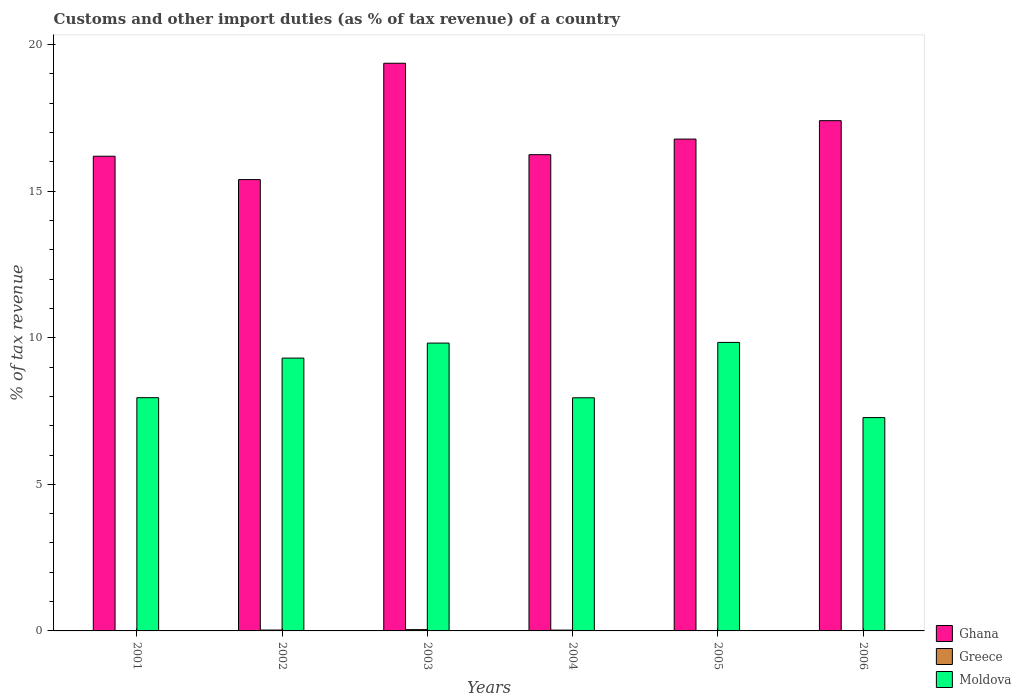How many different coloured bars are there?
Provide a short and direct response. 3. How many groups of bars are there?
Make the answer very short. 6. Are the number of bars per tick equal to the number of legend labels?
Provide a succinct answer. No. How many bars are there on the 4th tick from the right?
Your answer should be compact. 3. What is the percentage of tax revenue from customs in Moldova in 2002?
Your answer should be compact. 9.31. Across all years, what is the maximum percentage of tax revenue from customs in Moldova?
Give a very brief answer. 9.84. Across all years, what is the minimum percentage of tax revenue from customs in Ghana?
Your answer should be very brief. 15.4. What is the total percentage of tax revenue from customs in Ghana in the graph?
Offer a very short reply. 101.38. What is the difference between the percentage of tax revenue from customs in Greece in 2004 and that in 2005?
Ensure brevity in your answer.  0.02. What is the difference between the percentage of tax revenue from customs in Ghana in 2003 and the percentage of tax revenue from customs in Moldova in 2002?
Keep it short and to the point. 10.06. What is the average percentage of tax revenue from customs in Moldova per year?
Your answer should be compact. 8.69. In the year 2005, what is the difference between the percentage of tax revenue from customs in Moldova and percentage of tax revenue from customs in Ghana?
Offer a terse response. -6.94. In how many years, is the percentage of tax revenue from customs in Moldova greater than 11 %?
Offer a terse response. 0. What is the ratio of the percentage of tax revenue from customs in Ghana in 2002 to that in 2005?
Your response must be concise. 0.92. What is the difference between the highest and the second highest percentage of tax revenue from customs in Ghana?
Your answer should be compact. 1.96. What is the difference between the highest and the lowest percentage of tax revenue from customs in Ghana?
Make the answer very short. 3.97. In how many years, is the percentage of tax revenue from customs in Greece greater than the average percentage of tax revenue from customs in Greece taken over all years?
Ensure brevity in your answer.  3. Is the sum of the percentage of tax revenue from customs in Ghana in 2001 and 2003 greater than the maximum percentage of tax revenue from customs in Greece across all years?
Provide a succinct answer. Yes. Is it the case that in every year, the sum of the percentage of tax revenue from customs in Greece and percentage of tax revenue from customs in Ghana is greater than the percentage of tax revenue from customs in Moldova?
Your answer should be compact. Yes. Are all the bars in the graph horizontal?
Your answer should be very brief. No. Are the values on the major ticks of Y-axis written in scientific E-notation?
Provide a short and direct response. No. Where does the legend appear in the graph?
Provide a succinct answer. Bottom right. How many legend labels are there?
Your answer should be compact. 3. What is the title of the graph?
Ensure brevity in your answer.  Customs and other import duties (as % of tax revenue) of a country. Does "Cabo Verde" appear as one of the legend labels in the graph?
Offer a terse response. No. What is the label or title of the Y-axis?
Your response must be concise. % of tax revenue. What is the % of tax revenue of Ghana in 2001?
Offer a terse response. 16.19. What is the % of tax revenue in Greece in 2001?
Your response must be concise. 0. What is the % of tax revenue of Moldova in 2001?
Offer a very short reply. 7.96. What is the % of tax revenue in Ghana in 2002?
Provide a short and direct response. 15.4. What is the % of tax revenue of Greece in 2002?
Offer a terse response. 0.03. What is the % of tax revenue of Moldova in 2002?
Your response must be concise. 9.31. What is the % of tax revenue in Ghana in 2003?
Provide a succinct answer. 19.36. What is the % of tax revenue of Greece in 2003?
Offer a terse response. 0.04. What is the % of tax revenue in Moldova in 2003?
Keep it short and to the point. 9.82. What is the % of tax revenue of Ghana in 2004?
Your answer should be very brief. 16.25. What is the % of tax revenue in Greece in 2004?
Ensure brevity in your answer.  0.03. What is the % of tax revenue in Moldova in 2004?
Your response must be concise. 7.95. What is the % of tax revenue of Ghana in 2005?
Offer a terse response. 16.78. What is the % of tax revenue in Greece in 2005?
Offer a very short reply. 0.01. What is the % of tax revenue in Moldova in 2005?
Keep it short and to the point. 9.84. What is the % of tax revenue in Ghana in 2006?
Offer a terse response. 17.41. What is the % of tax revenue of Greece in 2006?
Provide a succinct answer. 0.01. What is the % of tax revenue of Moldova in 2006?
Ensure brevity in your answer.  7.28. Across all years, what is the maximum % of tax revenue in Ghana?
Offer a very short reply. 19.36. Across all years, what is the maximum % of tax revenue of Greece?
Provide a short and direct response. 0.04. Across all years, what is the maximum % of tax revenue in Moldova?
Your answer should be compact. 9.84. Across all years, what is the minimum % of tax revenue of Ghana?
Ensure brevity in your answer.  15.4. Across all years, what is the minimum % of tax revenue in Moldova?
Offer a very short reply. 7.28. What is the total % of tax revenue of Ghana in the graph?
Your answer should be compact. 101.38. What is the total % of tax revenue of Greece in the graph?
Your response must be concise. 0.12. What is the total % of tax revenue in Moldova in the graph?
Make the answer very short. 52.15. What is the difference between the % of tax revenue in Ghana in 2001 and that in 2002?
Your response must be concise. 0.8. What is the difference between the % of tax revenue in Moldova in 2001 and that in 2002?
Provide a short and direct response. -1.35. What is the difference between the % of tax revenue in Ghana in 2001 and that in 2003?
Ensure brevity in your answer.  -3.17. What is the difference between the % of tax revenue of Moldova in 2001 and that in 2003?
Keep it short and to the point. -1.86. What is the difference between the % of tax revenue in Ghana in 2001 and that in 2004?
Your response must be concise. -0.05. What is the difference between the % of tax revenue in Moldova in 2001 and that in 2004?
Your answer should be compact. 0. What is the difference between the % of tax revenue of Ghana in 2001 and that in 2005?
Your answer should be compact. -0.58. What is the difference between the % of tax revenue of Moldova in 2001 and that in 2005?
Ensure brevity in your answer.  -1.89. What is the difference between the % of tax revenue of Ghana in 2001 and that in 2006?
Make the answer very short. -1.21. What is the difference between the % of tax revenue of Moldova in 2001 and that in 2006?
Make the answer very short. 0.68. What is the difference between the % of tax revenue in Ghana in 2002 and that in 2003?
Provide a short and direct response. -3.97. What is the difference between the % of tax revenue in Greece in 2002 and that in 2003?
Offer a very short reply. -0.01. What is the difference between the % of tax revenue in Moldova in 2002 and that in 2003?
Your answer should be compact. -0.51. What is the difference between the % of tax revenue in Ghana in 2002 and that in 2004?
Give a very brief answer. -0.85. What is the difference between the % of tax revenue of Greece in 2002 and that in 2004?
Your answer should be very brief. 0. What is the difference between the % of tax revenue of Moldova in 2002 and that in 2004?
Offer a very short reply. 1.35. What is the difference between the % of tax revenue in Ghana in 2002 and that in 2005?
Give a very brief answer. -1.38. What is the difference between the % of tax revenue in Greece in 2002 and that in 2005?
Your answer should be compact. 0.02. What is the difference between the % of tax revenue of Moldova in 2002 and that in 2005?
Ensure brevity in your answer.  -0.54. What is the difference between the % of tax revenue in Ghana in 2002 and that in 2006?
Give a very brief answer. -2.01. What is the difference between the % of tax revenue in Greece in 2002 and that in 2006?
Make the answer very short. 0.02. What is the difference between the % of tax revenue of Moldova in 2002 and that in 2006?
Your response must be concise. 2.03. What is the difference between the % of tax revenue in Ghana in 2003 and that in 2004?
Offer a terse response. 3.12. What is the difference between the % of tax revenue in Greece in 2003 and that in 2004?
Offer a very short reply. 0.02. What is the difference between the % of tax revenue in Moldova in 2003 and that in 2004?
Give a very brief answer. 1.87. What is the difference between the % of tax revenue of Ghana in 2003 and that in 2005?
Your response must be concise. 2.59. What is the difference between the % of tax revenue in Greece in 2003 and that in 2005?
Your answer should be very brief. 0.04. What is the difference between the % of tax revenue in Moldova in 2003 and that in 2005?
Provide a succinct answer. -0.02. What is the difference between the % of tax revenue of Ghana in 2003 and that in 2006?
Keep it short and to the point. 1.96. What is the difference between the % of tax revenue of Greece in 2003 and that in 2006?
Your response must be concise. 0.03. What is the difference between the % of tax revenue of Moldova in 2003 and that in 2006?
Provide a succinct answer. 2.54. What is the difference between the % of tax revenue in Ghana in 2004 and that in 2005?
Offer a terse response. -0.53. What is the difference between the % of tax revenue of Greece in 2004 and that in 2005?
Your response must be concise. 0.02. What is the difference between the % of tax revenue in Moldova in 2004 and that in 2005?
Give a very brief answer. -1.89. What is the difference between the % of tax revenue in Ghana in 2004 and that in 2006?
Provide a short and direct response. -1.16. What is the difference between the % of tax revenue of Greece in 2004 and that in 2006?
Your answer should be very brief. 0.02. What is the difference between the % of tax revenue of Moldova in 2004 and that in 2006?
Provide a short and direct response. 0.68. What is the difference between the % of tax revenue in Ghana in 2005 and that in 2006?
Give a very brief answer. -0.63. What is the difference between the % of tax revenue in Greece in 2005 and that in 2006?
Your answer should be compact. -0. What is the difference between the % of tax revenue in Moldova in 2005 and that in 2006?
Offer a very short reply. 2.56. What is the difference between the % of tax revenue in Ghana in 2001 and the % of tax revenue in Greece in 2002?
Make the answer very short. 16.16. What is the difference between the % of tax revenue of Ghana in 2001 and the % of tax revenue of Moldova in 2002?
Keep it short and to the point. 6.89. What is the difference between the % of tax revenue of Ghana in 2001 and the % of tax revenue of Greece in 2003?
Your answer should be compact. 16.15. What is the difference between the % of tax revenue of Ghana in 2001 and the % of tax revenue of Moldova in 2003?
Provide a succinct answer. 6.37. What is the difference between the % of tax revenue in Ghana in 2001 and the % of tax revenue in Greece in 2004?
Keep it short and to the point. 16.17. What is the difference between the % of tax revenue of Ghana in 2001 and the % of tax revenue of Moldova in 2004?
Offer a terse response. 8.24. What is the difference between the % of tax revenue in Ghana in 2001 and the % of tax revenue in Greece in 2005?
Ensure brevity in your answer.  16.19. What is the difference between the % of tax revenue of Ghana in 2001 and the % of tax revenue of Moldova in 2005?
Ensure brevity in your answer.  6.35. What is the difference between the % of tax revenue of Ghana in 2001 and the % of tax revenue of Greece in 2006?
Make the answer very short. 16.18. What is the difference between the % of tax revenue in Ghana in 2001 and the % of tax revenue in Moldova in 2006?
Your answer should be compact. 8.92. What is the difference between the % of tax revenue in Ghana in 2002 and the % of tax revenue in Greece in 2003?
Your answer should be very brief. 15.35. What is the difference between the % of tax revenue in Ghana in 2002 and the % of tax revenue in Moldova in 2003?
Make the answer very short. 5.58. What is the difference between the % of tax revenue of Greece in 2002 and the % of tax revenue of Moldova in 2003?
Ensure brevity in your answer.  -9.79. What is the difference between the % of tax revenue of Ghana in 2002 and the % of tax revenue of Greece in 2004?
Offer a very short reply. 15.37. What is the difference between the % of tax revenue in Ghana in 2002 and the % of tax revenue in Moldova in 2004?
Give a very brief answer. 7.44. What is the difference between the % of tax revenue in Greece in 2002 and the % of tax revenue in Moldova in 2004?
Keep it short and to the point. -7.92. What is the difference between the % of tax revenue of Ghana in 2002 and the % of tax revenue of Greece in 2005?
Your response must be concise. 15.39. What is the difference between the % of tax revenue of Ghana in 2002 and the % of tax revenue of Moldova in 2005?
Give a very brief answer. 5.55. What is the difference between the % of tax revenue in Greece in 2002 and the % of tax revenue in Moldova in 2005?
Keep it short and to the point. -9.81. What is the difference between the % of tax revenue in Ghana in 2002 and the % of tax revenue in Greece in 2006?
Your answer should be compact. 15.39. What is the difference between the % of tax revenue in Ghana in 2002 and the % of tax revenue in Moldova in 2006?
Make the answer very short. 8.12. What is the difference between the % of tax revenue in Greece in 2002 and the % of tax revenue in Moldova in 2006?
Your response must be concise. -7.25. What is the difference between the % of tax revenue in Ghana in 2003 and the % of tax revenue in Greece in 2004?
Offer a terse response. 19.34. What is the difference between the % of tax revenue of Ghana in 2003 and the % of tax revenue of Moldova in 2004?
Offer a very short reply. 11.41. What is the difference between the % of tax revenue of Greece in 2003 and the % of tax revenue of Moldova in 2004?
Your response must be concise. -7.91. What is the difference between the % of tax revenue of Ghana in 2003 and the % of tax revenue of Greece in 2005?
Keep it short and to the point. 19.36. What is the difference between the % of tax revenue in Ghana in 2003 and the % of tax revenue in Moldova in 2005?
Give a very brief answer. 9.52. What is the difference between the % of tax revenue in Greece in 2003 and the % of tax revenue in Moldova in 2005?
Provide a short and direct response. -9.8. What is the difference between the % of tax revenue in Ghana in 2003 and the % of tax revenue in Greece in 2006?
Keep it short and to the point. 19.36. What is the difference between the % of tax revenue of Ghana in 2003 and the % of tax revenue of Moldova in 2006?
Give a very brief answer. 12.09. What is the difference between the % of tax revenue of Greece in 2003 and the % of tax revenue of Moldova in 2006?
Provide a succinct answer. -7.23. What is the difference between the % of tax revenue of Ghana in 2004 and the % of tax revenue of Greece in 2005?
Make the answer very short. 16.24. What is the difference between the % of tax revenue of Ghana in 2004 and the % of tax revenue of Moldova in 2005?
Your answer should be very brief. 6.4. What is the difference between the % of tax revenue in Greece in 2004 and the % of tax revenue in Moldova in 2005?
Your response must be concise. -9.81. What is the difference between the % of tax revenue in Ghana in 2004 and the % of tax revenue in Greece in 2006?
Provide a short and direct response. 16.24. What is the difference between the % of tax revenue in Ghana in 2004 and the % of tax revenue in Moldova in 2006?
Offer a very short reply. 8.97. What is the difference between the % of tax revenue of Greece in 2004 and the % of tax revenue of Moldova in 2006?
Ensure brevity in your answer.  -7.25. What is the difference between the % of tax revenue in Ghana in 2005 and the % of tax revenue in Greece in 2006?
Ensure brevity in your answer.  16.77. What is the difference between the % of tax revenue in Ghana in 2005 and the % of tax revenue in Moldova in 2006?
Keep it short and to the point. 9.5. What is the difference between the % of tax revenue of Greece in 2005 and the % of tax revenue of Moldova in 2006?
Ensure brevity in your answer.  -7.27. What is the average % of tax revenue of Ghana per year?
Offer a very short reply. 16.9. What is the average % of tax revenue of Greece per year?
Offer a very short reply. 0.02. What is the average % of tax revenue of Moldova per year?
Make the answer very short. 8.69. In the year 2001, what is the difference between the % of tax revenue of Ghana and % of tax revenue of Moldova?
Provide a short and direct response. 8.24. In the year 2002, what is the difference between the % of tax revenue in Ghana and % of tax revenue in Greece?
Keep it short and to the point. 15.37. In the year 2002, what is the difference between the % of tax revenue of Ghana and % of tax revenue of Moldova?
Your answer should be very brief. 6.09. In the year 2002, what is the difference between the % of tax revenue of Greece and % of tax revenue of Moldova?
Make the answer very short. -9.28. In the year 2003, what is the difference between the % of tax revenue of Ghana and % of tax revenue of Greece?
Provide a short and direct response. 19.32. In the year 2003, what is the difference between the % of tax revenue in Ghana and % of tax revenue in Moldova?
Your answer should be compact. 9.55. In the year 2003, what is the difference between the % of tax revenue in Greece and % of tax revenue in Moldova?
Offer a very short reply. -9.77. In the year 2004, what is the difference between the % of tax revenue of Ghana and % of tax revenue of Greece?
Keep it short and to the point. 16.22. In the year 2004, what is the difference between the % of tax revenue of Ghana and % of tax revenue of Moldova?
Ensure brevity in your answer.  8.29. In the year 2004, what is the difference between the % of tax revenue of Greece and % of tax revenue of Moldova?
Make the answer very short. -7.93. In the year 2005, what is the difference between the % of tax revenue in Ghana and % of tax revenue in Greece?
Offer a terse response. 16.77. In the year 2005, what is the difference between the % of tax revenue in Ghana and % of tax revenue in Moldova?
Keep it short and to the point. 6.94. In the year 2005, what is the difference between the % of tax revenue in Greece and % of tax revenue in Moldova?
Keep it short and to the point. -9.83. In the year 2006, what is the difference between the % of tax revenue in Ghana and % of tax revenue in Greece?
Make the answer very short. 17.4. In the year 2006, what is the difference between the % of tax revenue of Ghana and % of tax revenue of Moldova?
Make the answer very short. 10.13. In the year 2006, what is the difference between the % of tax revenue in Greece and % of tax revenue in Moldova?
Give a very brief answer. -7.27. What is the ratio of the % of tax revenue in Ghana in 2001 to that in 2002?
Your response must be concise. 1.05. What is the ratio of the % of tax revenue of Moldova in 2001 to that in 2002?
Your response must be concise. 0.85. What is the ratio of the % of tax revenue in Ghana in 2001 to that in 2003?
Keep it short and to the point. 0.84. What is the ratio of the % of tax revenue in Moldova in 2001 to that in 2003?
Offer a very short reply. 0.81. What is the ratio of the % of tax revenue of Ghana in 2001 to that in 2005?
Provide a short and direct response. 0.97. What is the ratio of the % of tax revenue of Moldova in 2001 to that in 2005?
Offer a terse response. 0.81. What is the ratio of the % of tax revenue of Ghana in 2001 to that in 2006?
Offer a very short reply. 0.93. What is the ratio of the % of tax revenue in Moldova in 2001 to that in 2006?
Provide a short and direct response. 1.09. What is the ratio of the % of tax revenue of Ghana in 2002 to that in 2003?
Give a very brief answer. 0.8. What is the ratio of the % of tax revenue of Greece in 2002 to that in 2003?
Ensure brevity in your answer.  0.68. What is the ratio of the % of tax revenue in Moldova in 2002 to that in 2003?
Offer a terse response. 0.95. What is the ratio of the % of tax revenue of Ghana in 2002 to that in 2004?
Keep it short and to the point. 0.95. What is the ratio of the % of tax revenue in Greece in 2002 to that in 2004?
Give a very brief answer. 1.08. What is the ratio of the % of tax revenue in Moldova in 2002 to that in 2004?
Ensure brevity in your answer.  1.17. What is the ratio of the % of tax revenue of Ghana in 2002 to that in 2005?
Keep it short and to the point. 0.92. What is the ratio of the % of tax revenue in Greece in 2002 to that in 2005?
Keep it short and to the point. 3.9. What is the ratio of the % of tax revenue of Moldova in 2002 to that in 2005?
Your answer should be very brief. 0.95. What is the ratio of the % of tax revenue in Ghana in 2002 to that in 2006?
Your answer should be very brief. 0.88. What is the ratio of the % of tax revenue of Greece in 2002 to that in 2006?
Give a very brief answer. 3.19. What is the ratio of the % of tax revenue in Moldova in 2002 to that in 2006?
Make the answer very short. 1.28. What is the ratio of the % of tax revenue in Ghana in 2003 to that in 2004?
Your answer should be compact. 1.19. What is the ratio of the % of tax revenue in Greece in 2003 to that in 2004?
Your answer should be compact. 1.6. What is the ratio of the % of tax revenue of Moldova in 2003 to that in 2004?
Your answer should be compact. 1.23. What is the ratio of the % of tax revenue in Ghana in 2003 to that in 2005?
Your response must be concise. 1.15. What is the ratio of the % of tax revenue in Greece in 2003 to that in 2005?
Provide a succinct answer. 5.76. What is the ratio of the % of tax revenue of Moldova in 2003 to that in 2005?
Provide a succinct answer. 1. What is the ratio of the % of tax revenue in Ghana in 2003 to that in 2006?
Your response must be concise. 1.11. What is the ratio of the % of tax revenue in Greece in 2003 to that in 2006?
Ensure brevity in your answer.  4.7. What is the ratio of the % of tax revenue in Moldova in 2003 to that in 2006?
Offer a very short reply. 1.35. What is the ratio of the % of tax revenue in Ghana in 2004 to that in 2005?
Give a very brief answer. 0.97. What is the ratio of the % of tax revenue of Greece in 2004 to that in 2005?
Your answer should be very brief. 3.61. What is the ratio of the % of tax revenue in Moldova in 2004 to that in 2005?
Keep it short and to the point. 0.81. What is the ratio of the % of tax revenue in Ghana in 2004 to that in 2006?
Ensure brevity in your answer.  0.93. What is the ratio of the % of tax revenue in Greece in 2004 to that in 2006?
Keep it short and to the point. 2.94. What is the ratio of the % of tax revenue of Moldova in 2004 to that in 2006?
Ensure brevity in your answer.  1.09. What is the ratio of the % of tax revenue in Ghana in 2005 to that in 2006?
Give a very brief answer. 0.96. What is the ratio of the % of tax revenue of Greece in 2005 to that in 2006?
Make the answer very short. 0.82. What is the ratio of the % of tax revenue of Moldova in 2005 to that in 2006?
Make the answer very short. 1.35. What is the difference between the highest and the second highest % of tax revenue of Ghana?
Offer a very short reply. 1.96. What is the difference between the highest and the second highest % of tax revenue in Greece?
Your response must be concise. 0.01. What is the difference between the highest and the second highest % of tax revenue of Moldova?
Your answer should be very brief. 0.02. What is the difference between the highest and the lowest % of tax revenue of Ghana?
Provide a succinct answer. 3.97. What is the difference between the highest and the lowest % of tax revenue of Greece?
Your answer should be very brief. 0.04. What is the difference between the highest and the lowest % of tax revenue of Moldova?
Give a very brief answer. 2.56. 